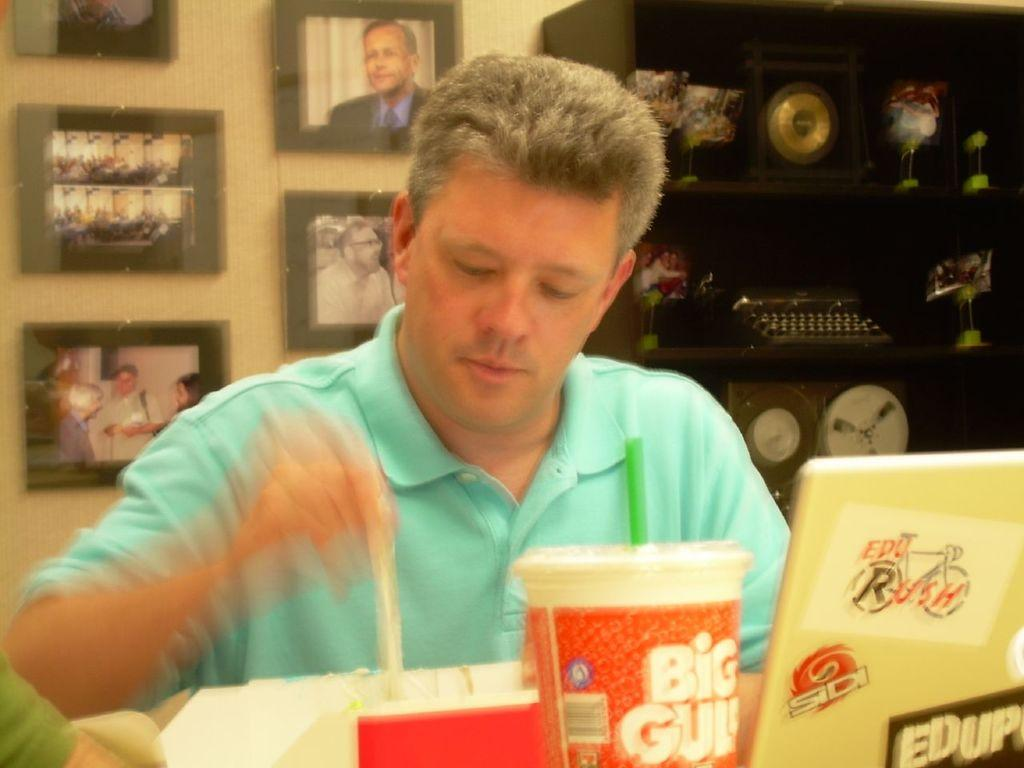Provide a one-sentence caption for the provided image. A man in a blue shirt is sitting at a table with a Big Gulp cup. 